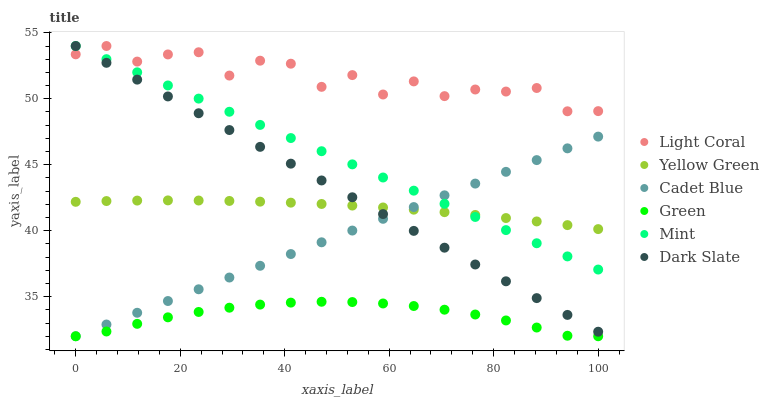Does Green have the minimum area under the curve?
Answer yes or no. Yes. Does Light Coral have the maximum area under the curve?
Answer yes or no. Yes. Does Yellow Green have the minimum area under the curve?
Answer yes or no. No. Does Yellow Green have the maximum area under the curve?
Answer yes or no. No. Is Mint the smoothest?
Answer yes or no. Yes. Is Light Coral the roughest?
Answer yes or no. Yes. Is Yellow Green the smoothest?
Answer yes or no. No. Is Yellow Green the roughest?
Answer yes or no. No. Does Cadet Blue have the lowest value?
Answer yes or no. Yes. Does Yellow Green have the lowest value?
Answer yes or no. No. Does Mint have the highest value?
Answer yes or no. Yes. Does Yellow Green have the highest value?
Answer yes or no. No. Is Green less than Mint?
Answer yes or no. Yes. Is Light Coral greater than Yellow Green?
Answer yes or no. Yes. Does Mint intersect Yellow Green?
Answer yes or no. Yes. Is Mint less than Yellow Green?
Answer yes or no. No. Is Mint greater than Yellow Green?
Answer yes or no. No. Does Green intersect Mint?
Answer yes or no. No. 